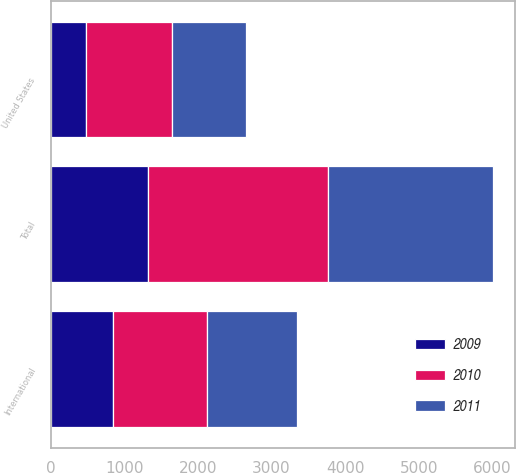<chart> <loc_0><loc_0><loc_500><loc_500><stacked_bar_chart><ecel><fcel>United States<fcel>International<fcel>Total<nl><fcel>2010<fcel>1168.1<fcel>1279.8<fcel>2447.9<nl><fcel>2011<fcel>1006.3<fcel>1223.3<fcel>2229.6<nl><fcel>2009<fcel>476.6<fcel>849.5<fcel>1326.1<nl></chart> 